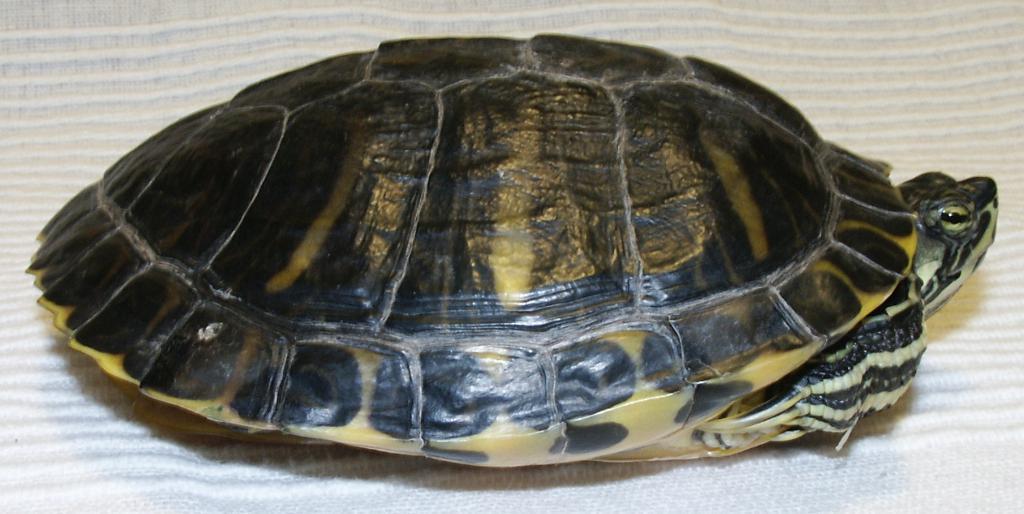How would you summarize this image in a sentence or two? In this image there is a turtle on the cloth. 